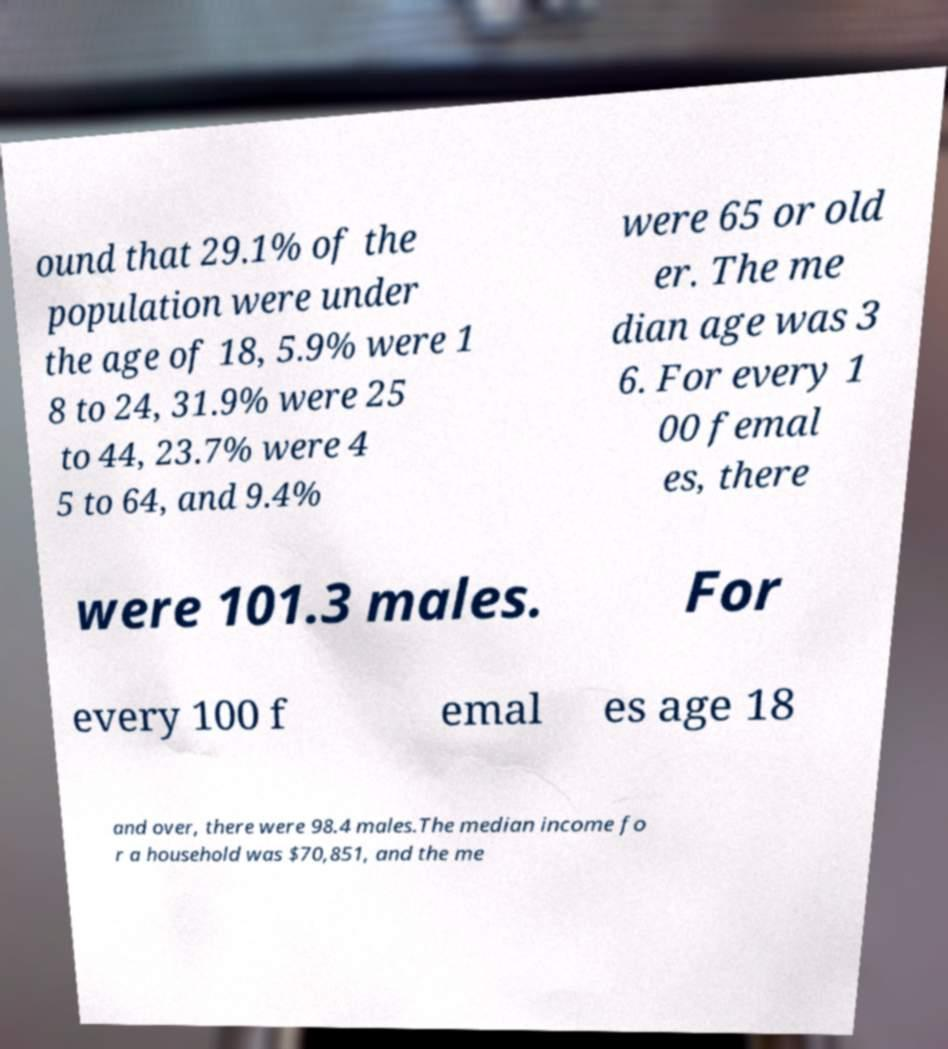Could you assist in decoding the text presented in this image and type it out clearly? ound that 29.1% of the population were under the age of 18, 5.9% were 1 8 to 24, 31.9% were 25 to 44, 23.7% were 4 5 to 64, and 9.4% were 65 or old er. The me dian age was 3 6. For every 1 00 femal es, there were 101.3 males. For every 100 f emal es age 18 and over, there were 98.4 males.The median income fo r a household was $70,851, and the me 